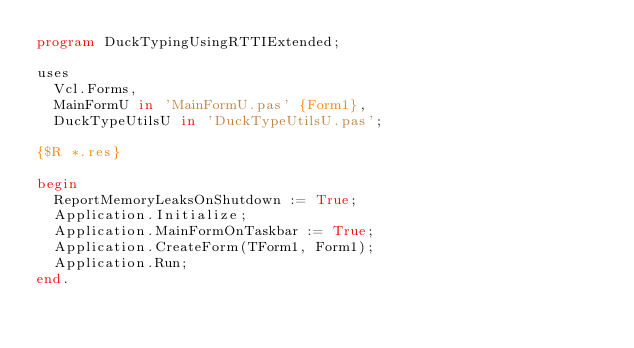Convert code to text. <code><loc_0><loc_0><loc_500><loc_500><_Pascal_>program DuckTypingUsingRTTIExtended;

uses
  Vcl.Forms,
  MainFormU in 'MainFormU.pas' {Form1},
  DuckTypeUtilsU in 'DuckTypeUtilsU.pas';

{$R *.res}

begin
  ReportMemoryLeaksOnShutdown := True;
  Application.Initialize;
  Application.MainFormOnTaskbar := True;
  Application.CreateForm(TForm1, Form1);
  Application.Run;
end.
</code> 